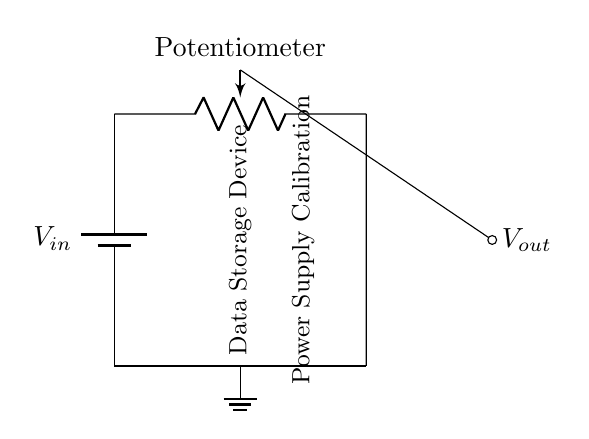What is the input voltage of the circuit? The input voltage, denoted as V_in, is represented by the battery symbol in the circuit diagram, which is connected at the left side of the circuit.
Answer: V_in What is the primary component used for adjusting the output voltage? The primary component used for adjusting the output voltage is the potentiometer, shown as a variable resistor in the circuit. Its variable setup allows for different voltage outputs depending on its wiper position.
Answer: Potentiometer What does the wiper of the potentiometer provide in this circuit? The wiper of the potentiometer provides the output voltage, V_out, as it can be adjusted to vary the potential difference taken from the potentiometer. The wiper is the point where the output voltage is measured from.
Answer: V_out How many nodes are there in the circuit? The circuit has a total of four distinct nodes: one at the positive terminal of the battery, one at the top end of the potentiometer, one at the ground, and one at the wiper where the output voltage is taken. Counting them gives the total.
Answer: Four What is the purpose of this circuit? The purpose of this circuit is for power supply calibration for a data storage device, as indicated by the labels in the diagram which specify the function of the output voltage connected to a storage device.
Answer: Calibration What happens to the output voltage when the potentiometer wiper is moved? When the wiper of the potentiometer is moved, the output voltage varies between 0 to V_in, depending on the position of the wiper, due to the voltage division principle where the resistance ratios affect the output.
Answer: Varies between 0 to V_in Which component is grounded in this circuit? The ground symbol denotes the node that is connected to the reference point (ground) in the circuit, which helps in completing the circuit allowing for voltage measurements and functioning properly.
Answer: Ground 